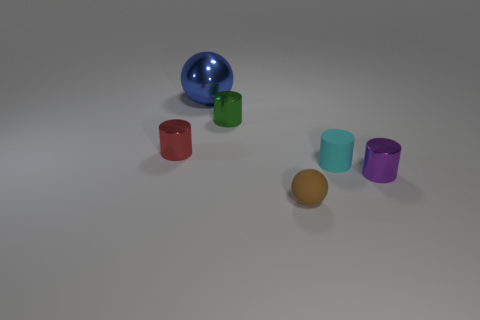Add 1 tiny matte things. How many objects exist? 7 Subtract all cylinders. How many objects are left? 2 Add 1 tiny cyan shiny spheres. How many tiny cyan shiny spheres exist? 1 Subtract 1 blue balls. How many objects are left? 5 Subtract all blue shiny balls. Subtract all green shiny cubes. How many objects are left? 5 Add 2 blue objects. How many blue objects are left? 3 